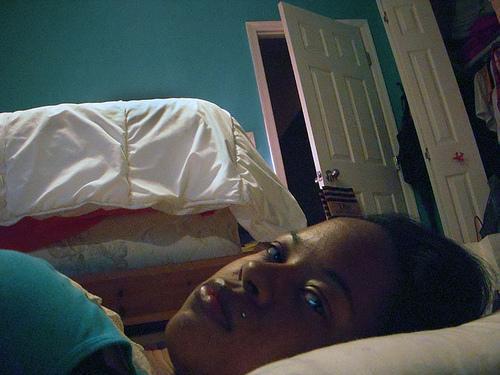How many people are in the photo?
Give a very brief answer. 1. 